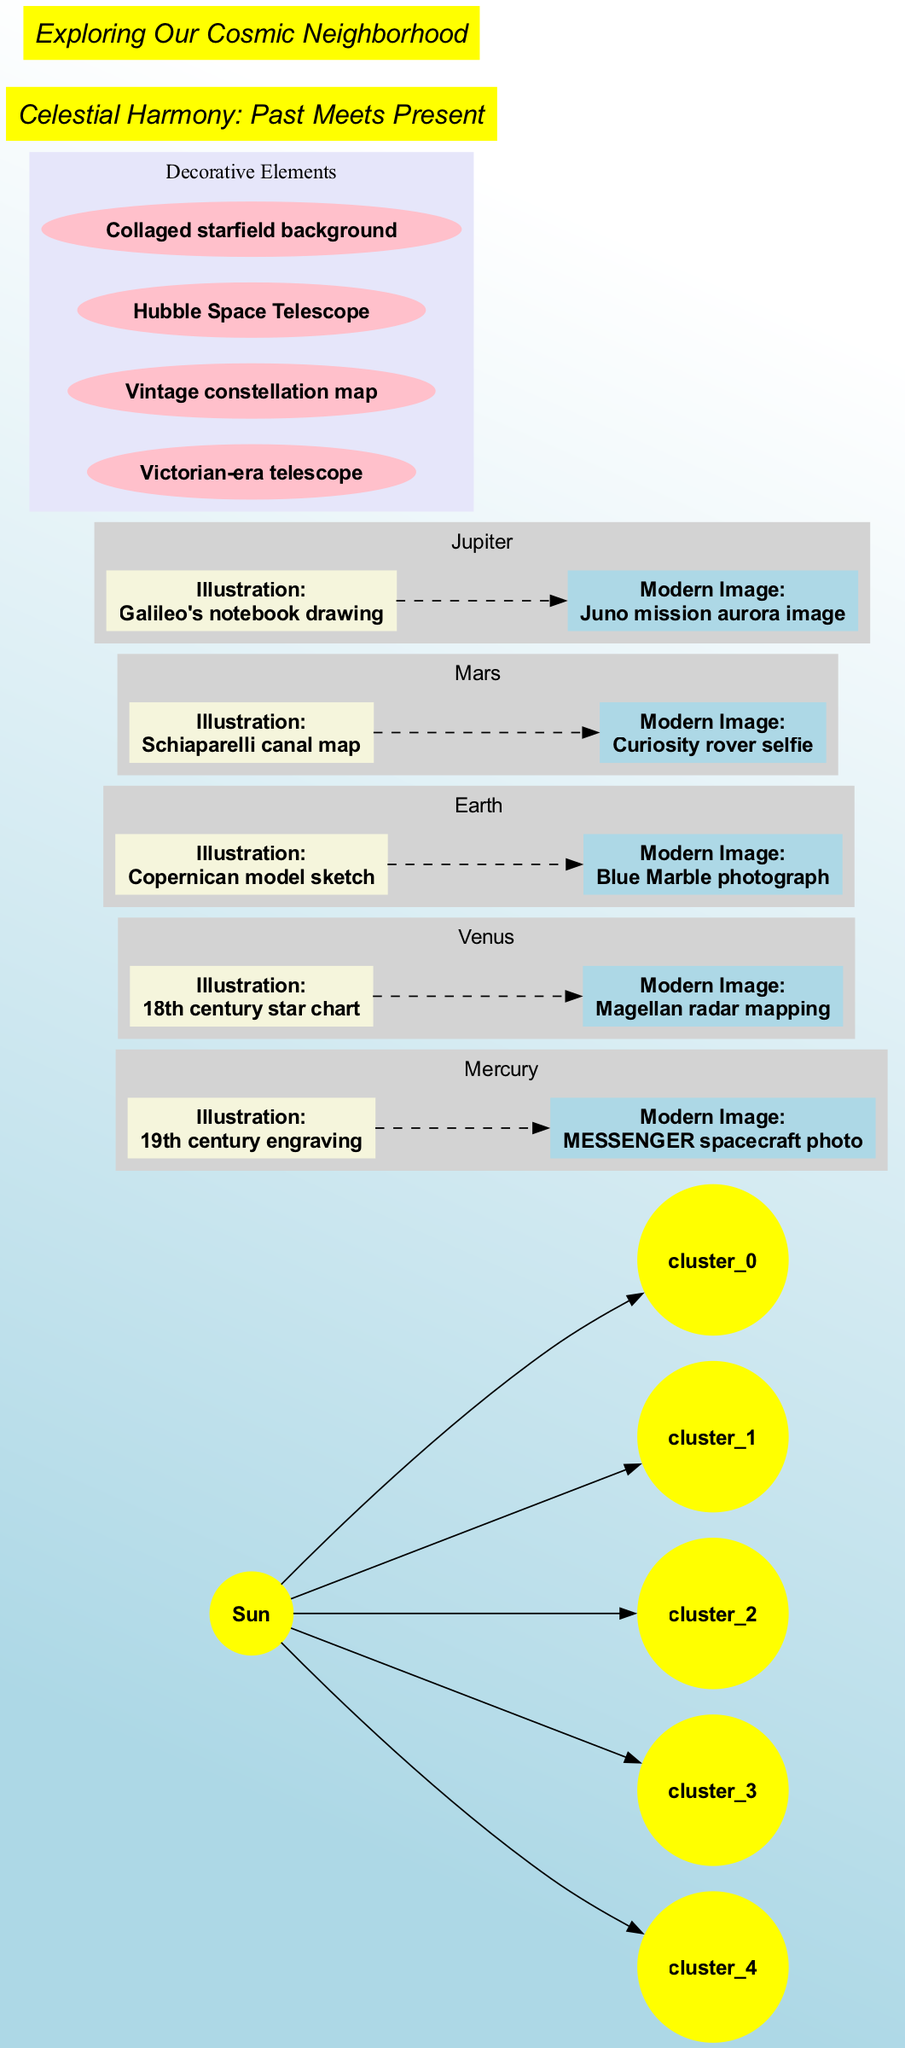What is the central element of the solar system? The central element of the solar system is depicted as the Sun, which is clearly labeled in the diagram.
Answer: Sun How many planetary bodies are featured in the diagram? By counting the individual planetary bodies listed in the diagram, we can see that there are five: Mercury, Venus, Earth, Mars, and Jupiter.
Answer: 5 Which planet's modern image is a Curiosity rover selfie? The diagram lists Mars' modern image as a Curiosity rover selfie, which is specifically labeled under Mars in the planetary bodies section.
Answer: Mars What type of illustration is associated with Venus? The illustration for Venus is represented as an 18th century star chart, which is indicated in the description for Venus in the diagram.
Answer: 18th century star chart What is the color of the Sun node? The diagram specifies that the Sun node is colored yellow, reflecting its representation in the diagram's design choices.
Answer: Yellow Which decorative element is related to telescopes? The decorative elements include a Victorian-era telescope, which is explicitly named among the other decorative features present on the diagram.
Answer: Victorian-era telescope How do the illustrations and modern images for a planet relate to each other? The relationship is visually represented through dashed lines connecting each illustration to its corresponding modern image, indicating a historical to contemporary transition for each planet.
Answer: Dashed lines What text overlay suggests a theme of cosmic exploration? The text overlay that refers to cosmic exploration is "Exploring Our Cosmic Neighborhood," which directly conveys the theme of the diagram.
Answer: Exploring Our Cosmic Neighborhood Which planet has a decorative cluster associated with its illustrations? Each planet, including Mercury and Venus, is housed in its decorative cluster as indicated by the labels assigned to the subgraphs, representing their respective illustrations and modern images.
Answer: All planets 